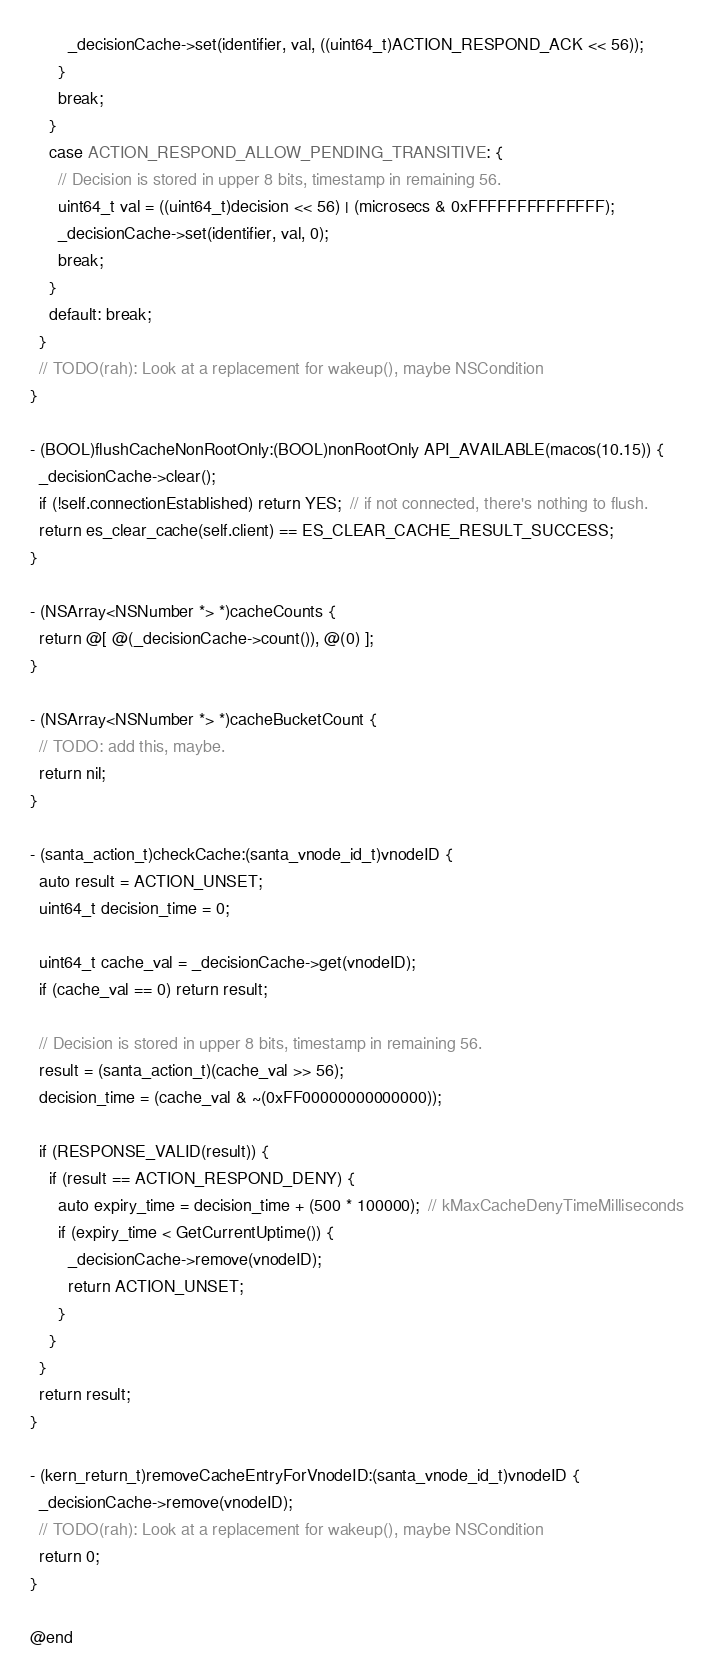<code> <loc_0><loc_0><loc_500><loc_500><_ObjectiveC_>        _decisionCache->set(identifier, val, ((uint64_t)ACTION_RESPOND_ACK << 56));
      }
      break;
    }
    case ACTION_RESPOND_ALLOW_PENDING_TRANSITIVE: {
      // Decision is stored in upper 8 bits, timestamp in remaining 56.
      uint64_t val = ((uint64_t)decision << 56) | (microsecs & 0xFFFFFFFFFFFFFF);
      _decisionCache->set(identifier, val, 0);
      break;
    }
    default: break;
  }
  // TODO(rah): Look at a replacement for wakeup(), maybe NSCondition
}

- (BOOL)flushCacheNonRootOnly:(BOOL)nonRootOnly API_AVAILABLE(macos(10.15)) {
  _decisionCache->clear();
  if (!self.connectionEstablished) return YES;  // if not connected, there's nothing to flush.
  return es_clear_cache(self.client) == ES_CLEAR_CACHE_RESULT_SUCCESS;
}

- (NSArray<NSNumber *> *)cacheCounts {
  return @[ @(_decisionCache->count()), @(0) ];
}

- (NSArray<NSNumber *> *)cacheBucketCount {
  // TODO: add this, maybe.
  return nil;
}

- (santa_action_t)checkCache:(santa_vnode_id_t)vnodeID {
  auto result = ACTION_UNSET;
  uint64_t decision_time = 0;

  uint64_t cache_val = _decisionCache->get(vnodeID);
  if (cache_val == 0) return result;

  // Decision is stored in upper 8 bits, timestamp in remaining 56.
  result = (santa_action_t)(cache_val >> 56);
  decision_time = (cache_val & ~(0xFF00000000000000));

  if (RESPONSE_VALID(result)) {
    if (result == ACTION_RESPOND_DENY) {
      auto expiry_time = decision_time + (500 * 100000);  // kMaxCacheDenyTimeMilliseconds
      if (expiry_time < GetCurrentUptime()) {
        _decisionCache->remove(vnodeID);
        return ACTION_UNSET;
      }
    }
  }
  return result;
}

- (kern_return_t)removeCacheEntryForVnodeID:(santa_vnode_id_t)vnodeID {
  _decisionCache->remove(vnodeID);
  // TODO(rah): Look at a replacement for wakeup(), maybe NSCondition
  return 0;
}

@end
</code> 